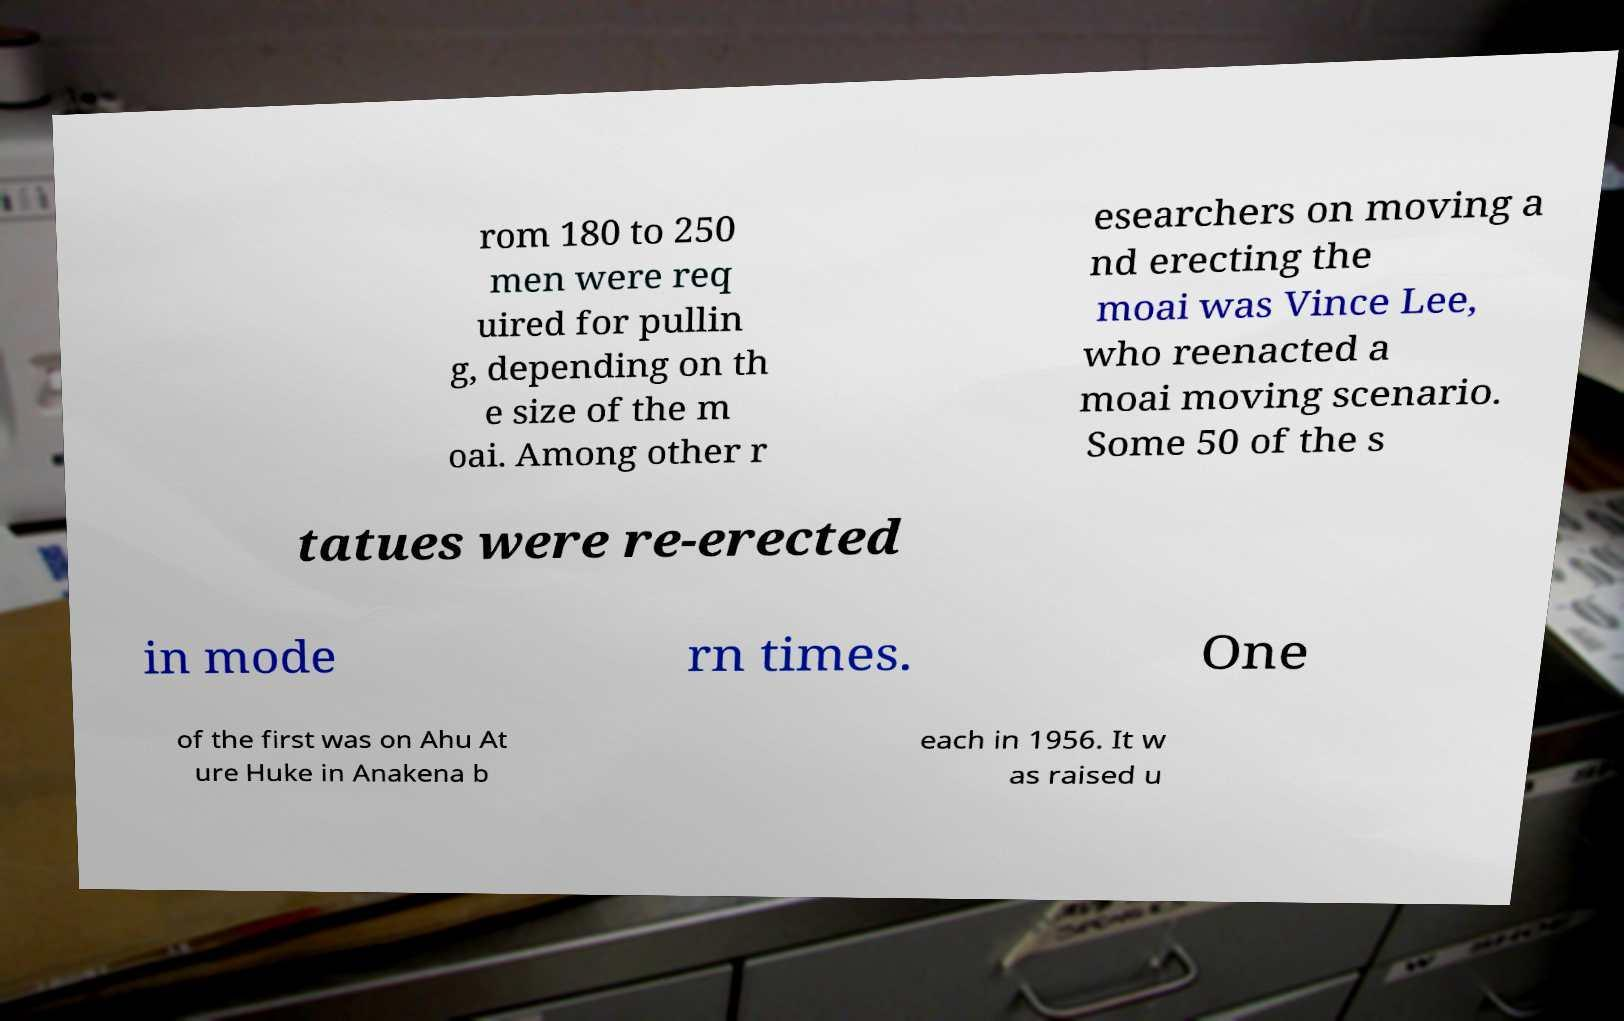Can you accurately transcribe the text from the provided image for me? rom 180 to 250 men were req uired for pullin g, depending on th e size of the m oai. Among other r esearchers on moving a nd erecting the moai was Vince Lee, who reenacted a moai moving scenario. Some 50 of the s tatues were re-erected in mode rn times. One of the first was on Ahu At ure Huke in Anakena b each in 1956. It w as raised u 